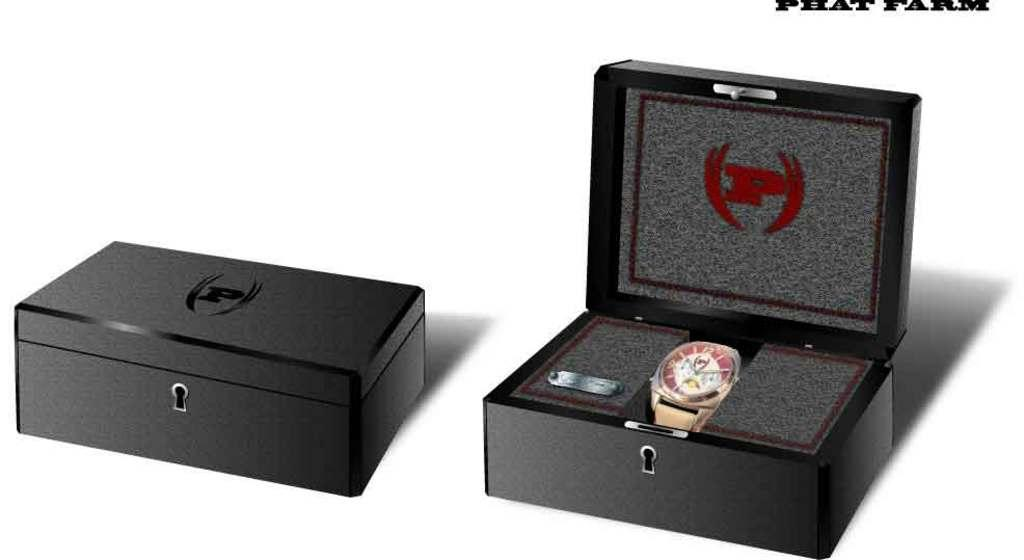<image>
Render a clear and concise summary of the photo. a nice black watch back that says 'p' on the top of it 